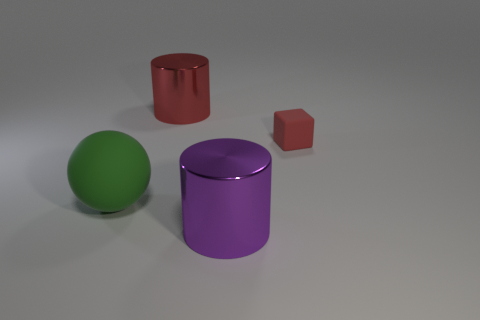How might the different textures of the objects impact how they interact with light? The objects seem to have matte finishes, which allows them to absorb and scatter light softly, resulting in diffused reflections and subtle shadows without distinct glossy highlights. 